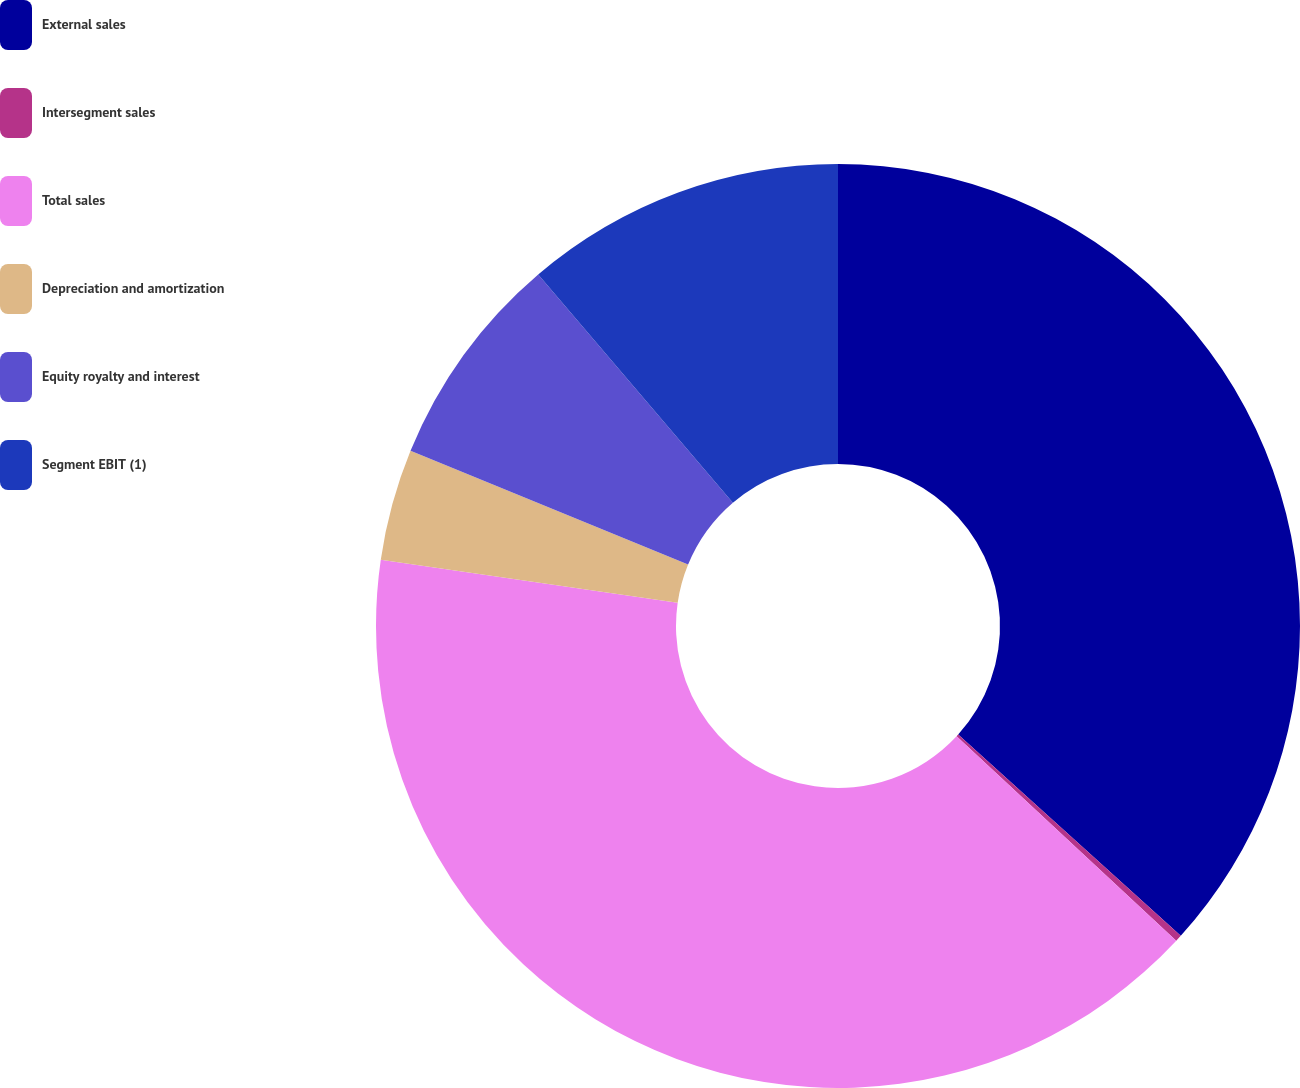Convert chart to OTSL. <chart><loc_0><loc_0><loc_500><loc_500><pie_chart><fcel>External sales<fcel>Intersegment sales<fcel>Total sales<fcel>Depreciation and amortization<fcel>Equity royalty and interest<fcel>Segment EBIT (1)<nl><fcel>36.7%<fcel>0.23%<fcel>40.37%<fcel>3.9%<fcel>7.57%<fcel>11.24%<nl></chart> 